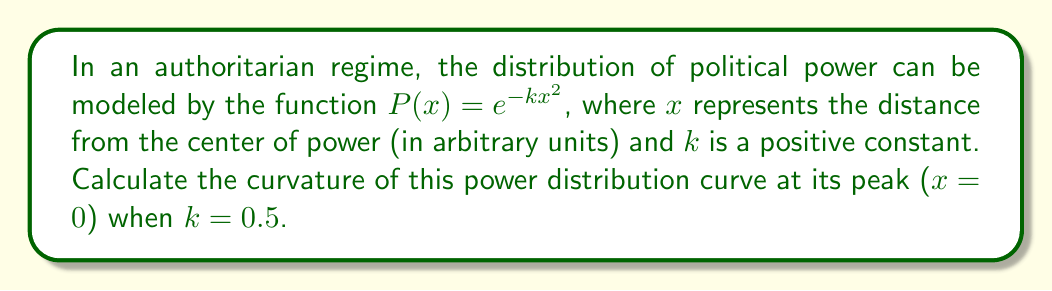Can you solve this math problem? To calculate the curvature of the political power distribution curve, we'll follow these steps:

1) The general formula for curvature of a function $y=f(x)$ is:

   $$\kappa = \frac{|f''(x)|}{(1+[f'(x)]^2)^{3/2}}$$

2) For our function $P(x) = e^{-kx^2}$, let's calculate the first and second derivatives:

   $P'(x) = -2kxe^{-kx^2}$
   $P''(x) = (-2k + 4k^2x^2)e^{-kx^2}$

3) At the peak ($x=0$):

   $P'(0) = 0$
   $P''(0) = -2ke^0 = -2k$

4) Substituting these into the curvature formula:

   $$\kappa = \frac{|-2k|}{(1+0^2)^{3/2}} = 2k$$

5) Given $k=0.5$, we can now calculate the curvature:

   $$\kappa = 2(0.5) = 1$$

This curvature value indicates how sharply the political power distribution curve bends at its peak, reflecting the concentration of power in the authoritarian regime.
Answer: $1$ 